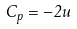Convert formula to latex. <formula><loc_0><loc_0><loc_500><loc_500>C _ { p } = - 2 u</formula> 